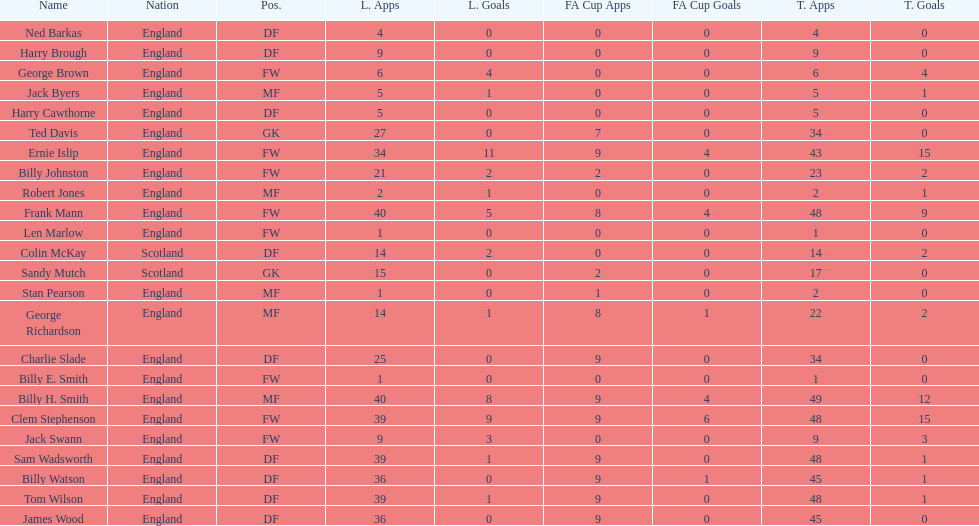The least number of total appearances 1. Could you help me parse every detail presented in this table? {'header': ['Name', 'Nation', 'Pos.', 'L. Apps', 'L. Goals', 'FA Cup Apps', 'FA Cup Goals', 'T. Apps', 'T. Goals'], 'rows': [['Ned Barkas', 'England', 'DF', '4', '0', '0', '0', '4', '0'], ['Harry Brough', 'England', 'DF', '9', '0', '0', '0', '9', '0'], ['George Brown', 'England', 'FW', '6', '4', '0', '0', '6', '4'], ['Jack Byers', 'England', 'MF', '5', '1', '0', '0', '5', '1'], ['Harry Cawthorne', 'England', 'DF', '5', '0', '0', '0', '5', '0'], ['Ted Davis', 'England', 'GK', '27', '0', '7', '0', '34', '0'], ['Ernie Islip', 'England', 'FW', '34', '11', '9', '4', '43', '15'], ['Billy Johnston', 'England', 'FW', '21', '2', '2', '0', '23', '2'], ['Robert Jones', 'England', 'MF', '2', '1', '0', '0', '2', '1'], ['Frank Mann', 'England', 'FW', '40', '5', '8', '4', '48', '9'], ['Len Marlow', 'England', 'FW', '1', '0', '0', '0', '1', '0'], ['Colin McKay', 'Scotland', 'DF', '14', '2', '0', '0', '14', '2'], ['Sandy Mutch', 'Scotland', 'GK', '15', '0', '2', '0', '17', '0'], ['Stan Pearson', 'England', 'MF', '1', '0', '1', '0', '2', '0'], ['George Richardson', 'England', 'MF', '14', '1', '8', '1', '22', '2'], ['Charlie Slade', 'England', 'DF', '25', '0', '9', '0', '34', '0'], ['Billy E. Smith', 'England', 'FW', '1', '0', '0', '0', '1', '0'], ['Billy H. Smith', 'England', 'MF', '40', '8', '9', '4', '49', '12'], ['Clem Stephenson', 'England', 'FW', '39', '9', '9', '6', '48', '15'], ['Jack Swann', 'England', 'FW', '9', '3', '0', '0', '9', '3'], ['Sam Wadsworth', 'England', 'DF', '39', '1', '9', '0', '48', '1'], ['Billy Watson', 'England', 'DF', '36', '0', '9', '1', '45', '1'], ['Tom Wilson', 'England', 'DF', '39', '1', '9', '0', '48', '1'], ['James Wood', 'England', 'DF', '36', '0', '9', '0', '45', '0']]} 